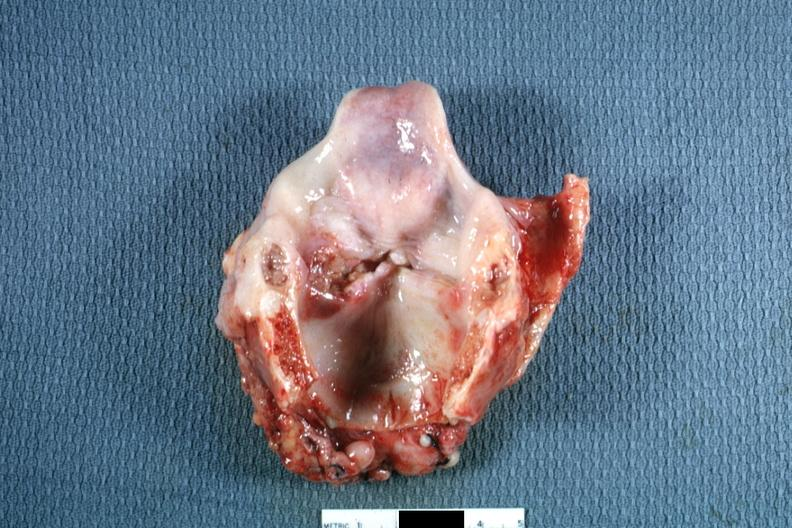s squamous cell carcinoma present?
Answer the question using a single word or phrase. Yes 